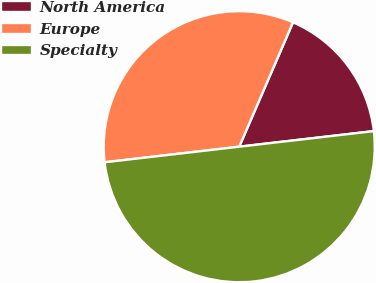Convert chart to OTSL. <chart><loc_0><loc_0><loc_500><loc_500><pie_chart><fcel>North America<fcel>Europe<fcel>Specialty<nl><fcel>16.67%<fcel>33.33%<fcel>50.0%<nl></chart> 